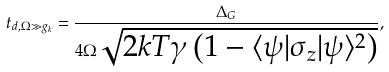<formula> <loc_0><loc_0><loc_500><loc_500>t _ { d , \Omega \gg g _ { k } } = \frac { \Delta _ { G } } { 4 \Omega \sqrt { 2 k T \gamma \left ( 1 - \langle \psi | \sigma _ { z } | \psi \rangle ^ { 2 } \right ) } } ,</formula> 